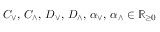Convert formula to latex. <formula><loc_0><loc_0><loc_500><loc_500>C _ { \vee } , \, C _ { \wedge } , \, D _ { \vee } , \, D _ { \wedge } , \, \alpha _ { \vee } , \, \alpha _ { \wedge } \in \mathbb { R } _ { \geq 0 }</formula> 